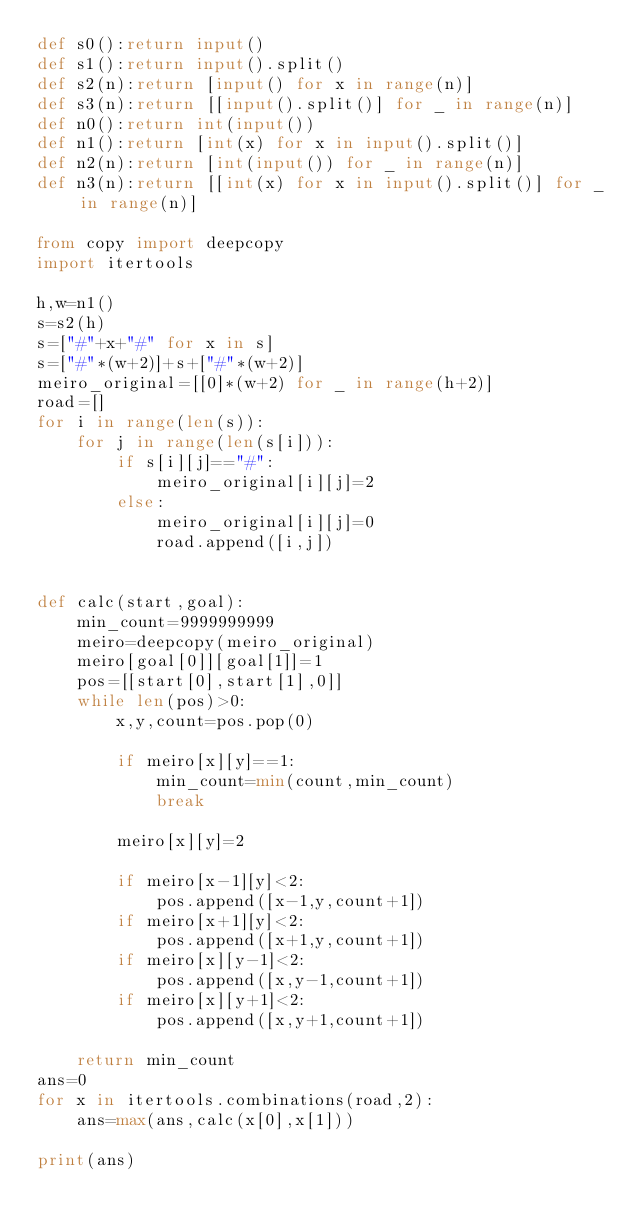Convert code to text. <code><loc_0><loc_0><loc_500><loc_500><_Python_>def s0():return input()
def s1():return input().split()
def s2(n):return [input() for x in range(n)]
def s3(n):return [[input().split()] for _ in range(n)]
def n0():return int(input())
def n1():return [int(x) for x in input().split()]
def n2(n):return [int(input()) for _ in range(n)]
def n3(n):return [[int(x) for x in input().split()] for _ in range(n)]

from copy import deepcopy
import itertools

h,w=n1()
s=s2(h)
s=["#"+x+"#" for x in s]
s=["#"*(w+2)]+s+["#"*(w+2)]
meiro_original=[[0]*(w+2) for _ in range(h+2)]
road=[]
for i in range(len(s)):
    for j in range(len(s[i])):
        if s[i][j]=="#":
            meiro_original[i][j]=2
        else:
            meiro_original[i][j]=0
            road.append([i,j])


def calc(start,goal):
    min_count=9999999999
    meiro=deepcopy(meiro_original)
    meiro[goal[0]][goal[1]]=1
    pos=[[start[0],start[1],0]]
    while len(pos)>0:
        x,y,count=pos.pop(0)

        if meiro[x][y]==1:
            min_count=min(count,min_count)
            break

        meiro[x][y]=2

        if meiro[x-1][y]<2:
            pos.append([x-1,y,count+1])    
        if meiro[x+1][y]<2:
            pos.append([x+1,y,count+1])    
        if meiro[x][y-1]<2:
            pos.append([x,y-1,count+1]) 
        if meiro[x][y+1]<2:
            pos.append([x,y+1,count+1])

    return min_count
ans=0
for x in itertools.combinations(road,2):
    ans=max(ans,calc(x[0],x[1]))
    
print(ans)</code> 